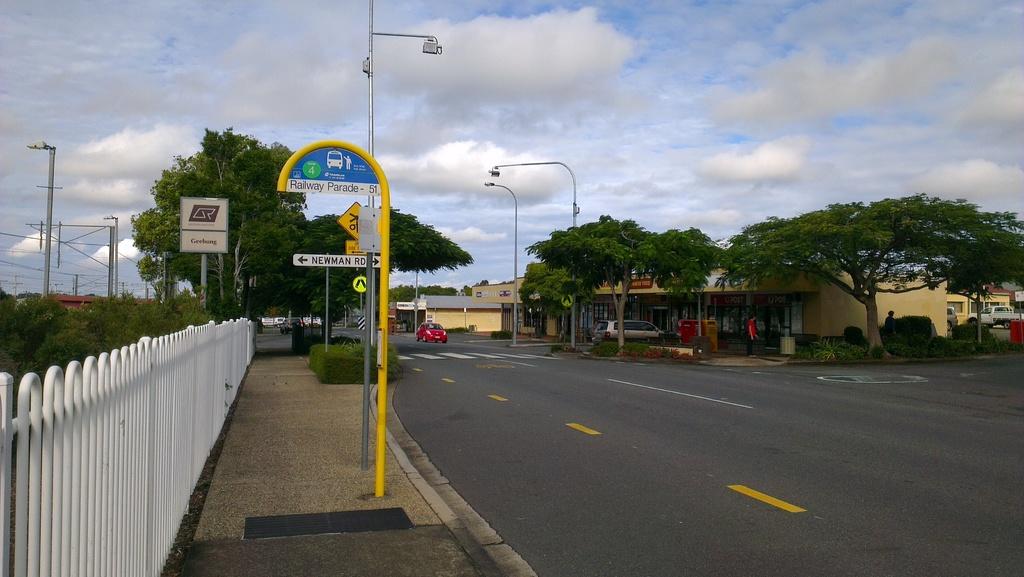What is the name of the road on the white sign?
Your response must be concise. Unanswerable. 